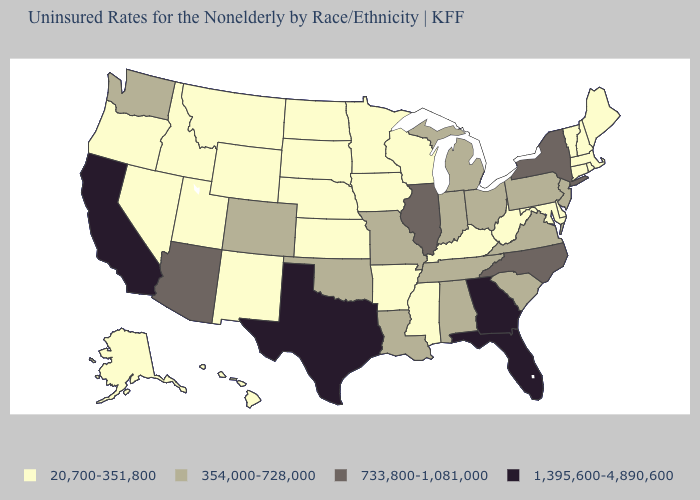What is the highest value in the South ?
Write a very short answer. 1,395,600-4,890,600. Does California have the highest value in the West?
Short answer required. Yes. What is the value of Maine?
Concise answer only. 20,700-351,800. What is the value of Mississippi?
Write a very short answer. 20,700-351,800. Does California have the highest value in the West?
Give a very brief answer. Yes. What is the value of Iowa?
Concise answer only. 20,700-351,800. Which states have the lowest value in the USA?
Give a very brief answer. Alaska, Arkansas, Connecticut, Delaware, Hawaii, Idaho, Iowa, Kansas, Kentucky, Maine, Maryland, Massachusetts, Minnesota, Mississippi, Montana, Nebraska, Nevada, New Hampshire, New Mexico, North Dakota, Oregon, Rhode Island, South Dakota, Utah, Vermont, West Virginia, Wisconsin, Wyoming. Is the legend a continuous bar?
Quick response, please. No. What is the lowest value in the USA?
Concise answer only. 20,700-351,800. Does New Mexico have the lowest value in the West?
Short answer required. Yes. Among the states that border Oregon , does California have the highest value?
Answer briefly. Yes. What is the value of Arizona?
Short answer required. 733,800-1,081,000. Does Tennessee have the same value as Illinois?
Concise answer only. No. Which states have the lowest value in the South?
Be succinct. Arkansas, Delaware, Kentucky, Maryland, Mississippi, West Virginia. Does the first symbol in the legend represent the smallest category?
Be succinct. Yes. 